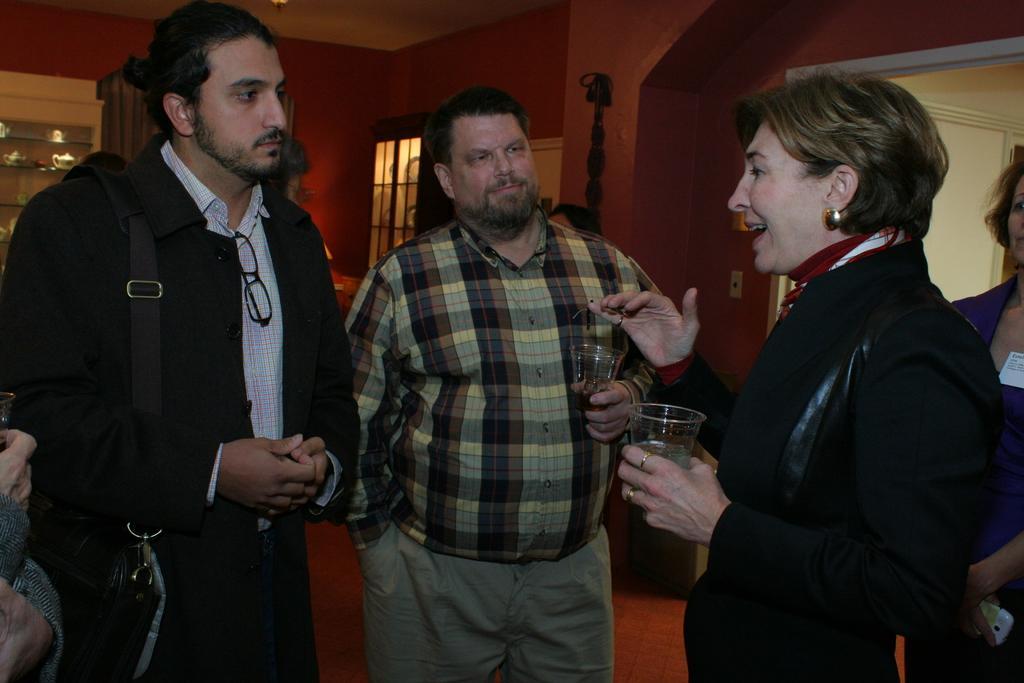In one or two sentences, can you explain what this image depicts? In this image we can see a man and a woman standing on the floor holding a glass. On the left side we can see a man wearing a bag. On the right side there is a woman holding a cellphone. On the backside we can see a wall, shelves, door and a window. 